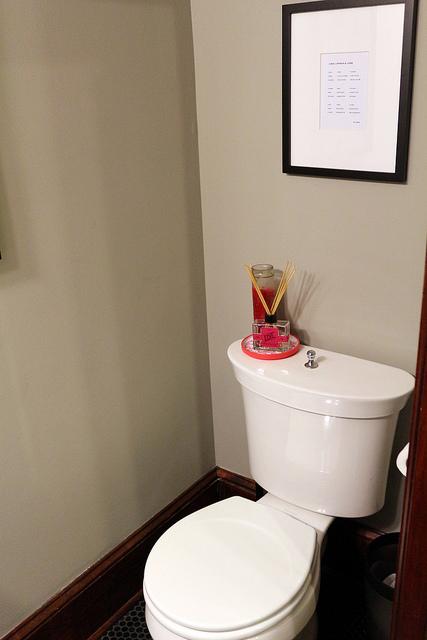What kind of room is this?
Give a very brief answer. Bathroom. What is the button for on top of lid?
Write a very short answer. Flush. Is there a jar candle on top of the toilet?
Give a very brief answer. Yes. 